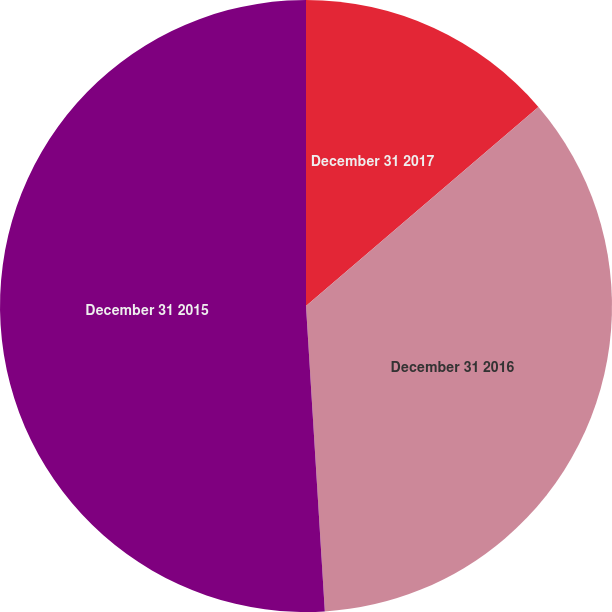Convert chart. <chart><loc_0><loc_0><loc_500><loc_500><pie_chart><fcel>December 31 2017<fcel>December 31 2016<fcel>December 31 2015<nl><fcel>13.73%<fcel>35.29%<fcel>50.98%<nl></chart> 